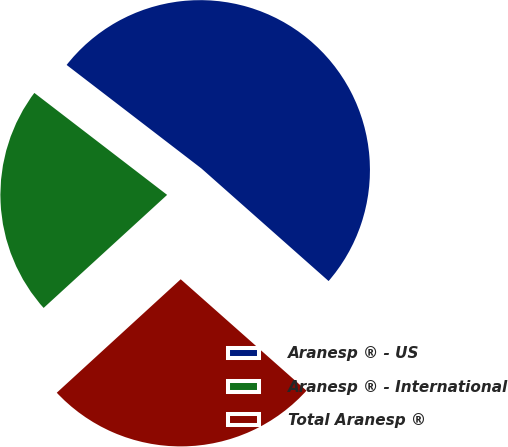<chart> <loc_0><loc_0><loc_500><loc_500><pie_chart><fcel>Aranesp ® - US<fcel>Aranesp ® - International<fcel>Total Aranesp ®<nl><fcel>51.11%<fcel>22.22%<fcel>26.67%<nl></chart> 